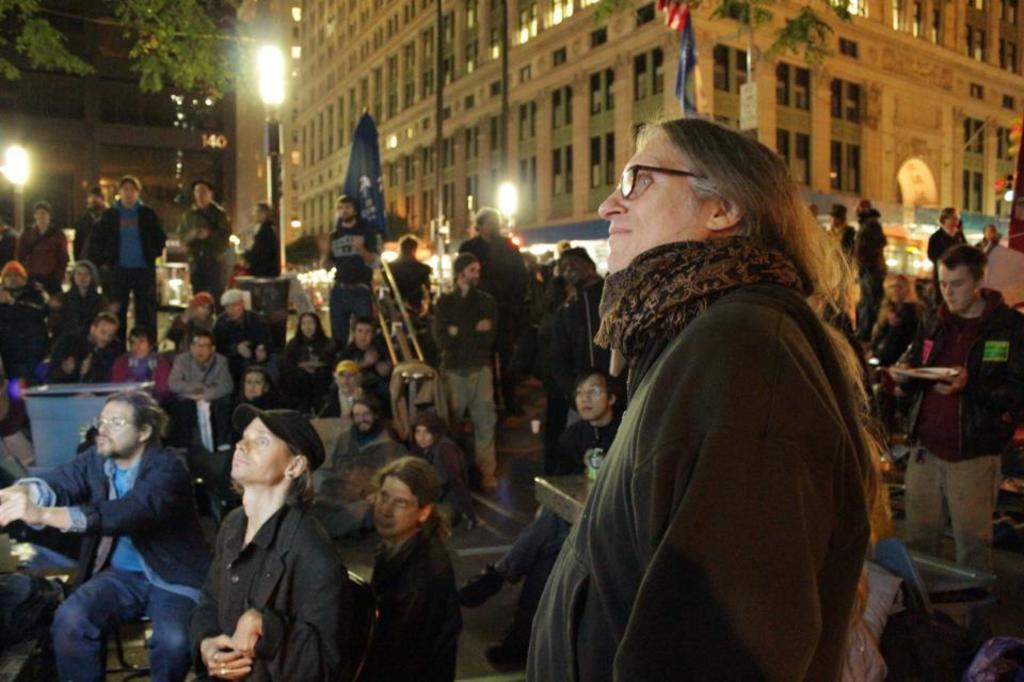Please provide a concise description of this image. In this image in the foreground there is one person who is standing, and in the background there are some people who are sitting and some of them are standing and some of them are doing somethings. In the background there are some buildings, trees, lights, poles and some flags. 